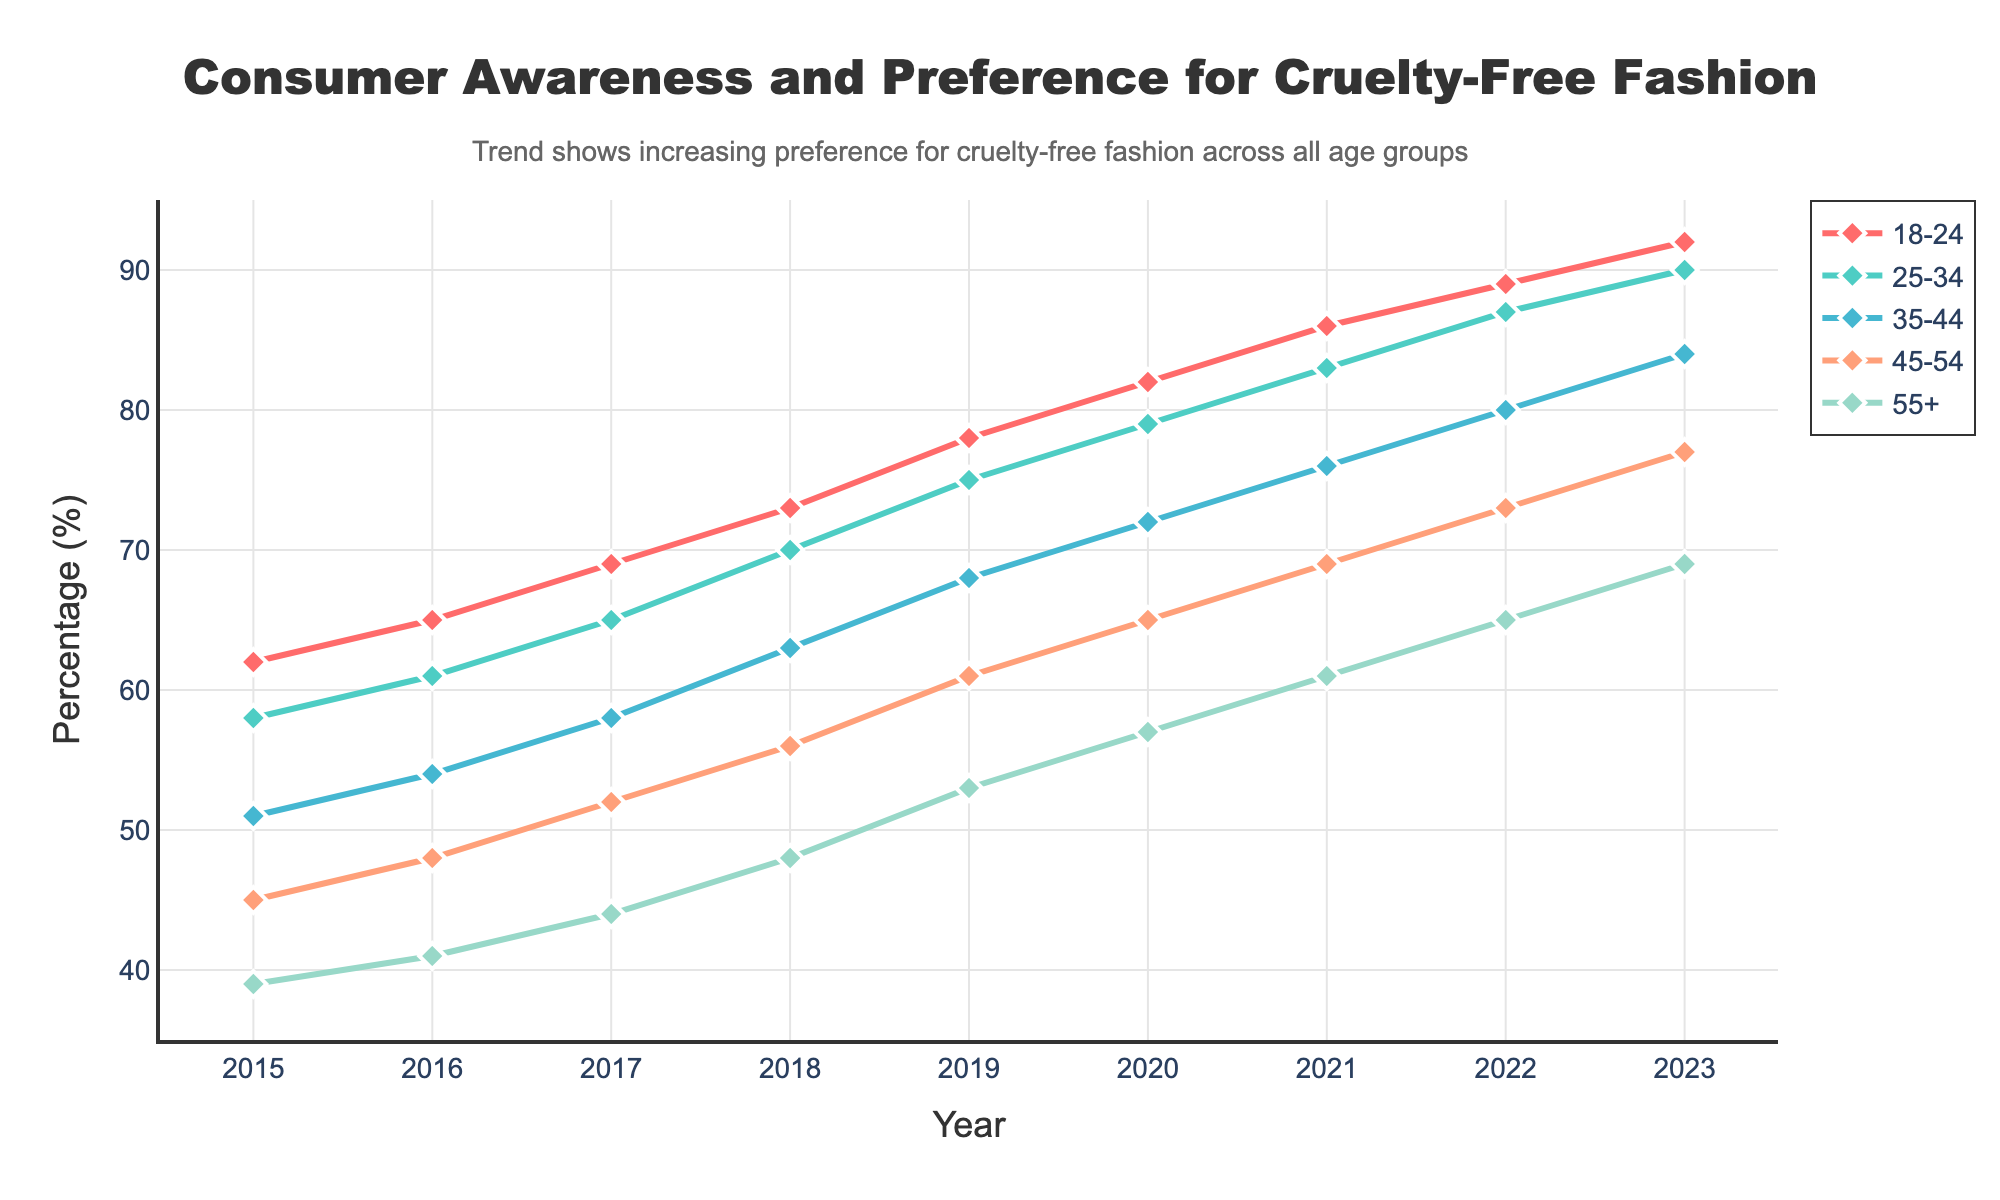What's the range of percentage increase from 2015 to 2023 for the age group 18-24? The percentage in 2015 for the 18-24 age group is 62, and in 2023 it is 92. The range of increase is calculated by subtracting the 2015 value from the 2023 value: 92 - 62 = 30.
Answer: 30 Which age group had the lowest consumer awareness and preference in 2015? In 2015, the percentages for each age group are: 18-24 (62), 25-34 (58), 35-44 (51), 45-54 (45), 55+ (39). The age group 55+ has the lowest percentage at 39.
Answer: 55+ How does the trend of consumer awareness for the 25-34 age group compare to the 45-54 age group over time? Both age groups show an increasing trend over time. However, the 25-34 age group consistently has higher percentages than the 45-54 age group in each year from 2015 to 2023. For example, in 2023, the 25-34 age group is at 90% while the 45-54 age group is at 77%.
Answer: 25-34 age group has higher percentages What is the average consumer awareness and preference percentage for the age group 35-44 over the years displayed? The percentages for the 35-44 age group from 2015 to 2023 are: 51, 54, 58, 63, 68, 72, 76, 80, 84. The average is found by summing these values and dividing by the number of years (9): (51 + 54 + 58 + 63 + 68 + 72 + 76 + 80 + 84) / 9 = 67.33.
Answer: 67.33 Did consumer awareness and preference for cruelty-free fashion in the age group 55+ ever exceed 60% in the given time frame? By observing the data, we see that the percentage for the 55+ age group never exceeds 60%, reaching a maximum of 69% in 2023.
Answer: No Which age group shows the most significant increase in consumer awareness and preference from 2015 to 2023? By calculating the difference for each age group from 2015 to 2023: 
- 18-24: 92 - 62 = 30
- 25-34: 90 - 58 = 32
- 35-44: 84 - 51 = 33
- 45-54: 77 - 45 = 32
- 55+: 69 - 39 = 30
The 35-44 age group shows the most significant increase of 33 percentage points.
Answer: 35-44 How do the percentages for the age group 18-24 in 2022 compare to the age group 55+ in 2022? In 2022, the percentage for the 18-24 age group is 89, while for the 55+ age group it is 65. The 18-24 age group has a higher percentage.
Answer: 18-24 age group has higher percentages What's the overall trend shown in the annotation of the figure? The annotation states that the trend shows an increasing preference for cruelty-free fashion across all age groups.
Answer: Increasing preference 